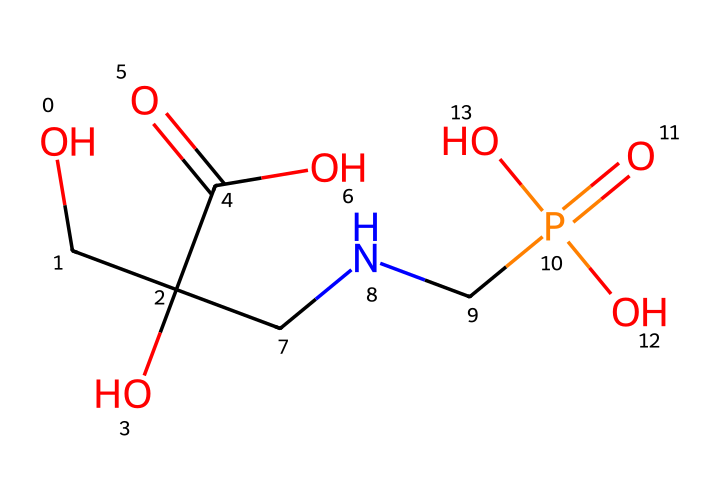How many carbon atoms are in glyphosate? By examining the structural formula represented in the SMILES string, we can identify the carbon atoms (C) present. The string includes parts like "C(=O)O" and branches like "C(O)(...)", which indicate there are a total of 3 carbon atoms in glyphosate.
Answer: 5 What is the molecular formula of glyphosate? By interpreting the SMILES, we can count each type of atom. The molecular formula consists of counting carbon (C), hydrogen (H), oxygen (O), and nitrogen (N) atoms directly from the notation. There are 3 carbon atoms, 8 hydrogen atoms, 4 oxygen atoms, and 1 nitrogen atom, which gives the molecular formula as C3H8N5O4.
Answer: C3H8N5O4 How many functional groups are present in glyphosate? The structure, as represented in the SMILES, includes several functional groups such as an amine (NH2), carboxylic acid (COOH), and a phosphate group (PO4). Counting all distinct functional groups, we find 3 different functional groups in glyphosate.
Answer: 3 What type of bonding is dominant in glyphosate? The SMILES representation shows multiple single and double bonds (noted by "C=C" for double bonds and "C-C" for single bonds). However, the most prominent bonds seen throughout the structure are the single covalent bonds connecting the various functional groups and backbone of the molecule, which indicates that single bonding is the dominant type.
Answer: covalent What is the primary purpose of glyphosate in agriculture? Glyphosate is well-known as a herbicide, designed specifically to kill weeds and is widely used in agricultural practices. The structural configuration indicates it targets and disrupts specific biochemical pathways in plants, making its primary purpose very clear.
Answer: herbicide Which part of glyphosate contributes to its herbicidal activity? The specificity in glyphosate’s herbicidal activity is primarily due to the phosphonyl group connected to the nitrogen, which interacts with key metabolic pathways in plants. Thus, the phosphorus-containing portion of the structure is crucial for its function.
Answer: phosphonyl group 